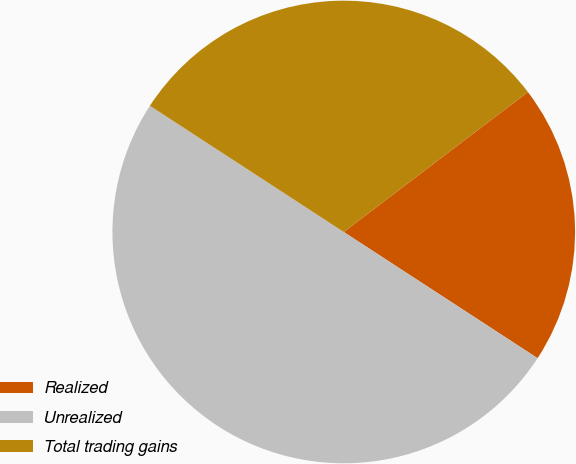<chart> <loc_0><loc_0><loc_500><loc_500><pie_chart><fcel>Realized<fcel>Unrealized<fcel>Total trading gains<nl><fcel>19.53%<fcel>50.0%<fcel>30.47%<nl></chart> 